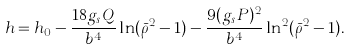Convert formula to latex. <formula><loc_0><loc_0><loc_500><loc_500>h = h _ { 0 } - \frac { 1 8 g _ { s } Q } { b ^ { 4 } } \ln ( \bar { \rho } ^ { 2 } - 1 ) - \frac { 9 ( g _ { s } P ) ^ { 2 } } { b ^ { 4 } } \ln ^ { 2 } ( \bar { \rho } ^ { 2 } - 1 ) .</formula> 